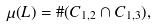<formula> <loc_0><loc_0><loc_500><loc_500>\mu ( L ) = \# ( C _ { 1 , 2 } \cap C _ { 1 , 3 } ) ,</formula> 